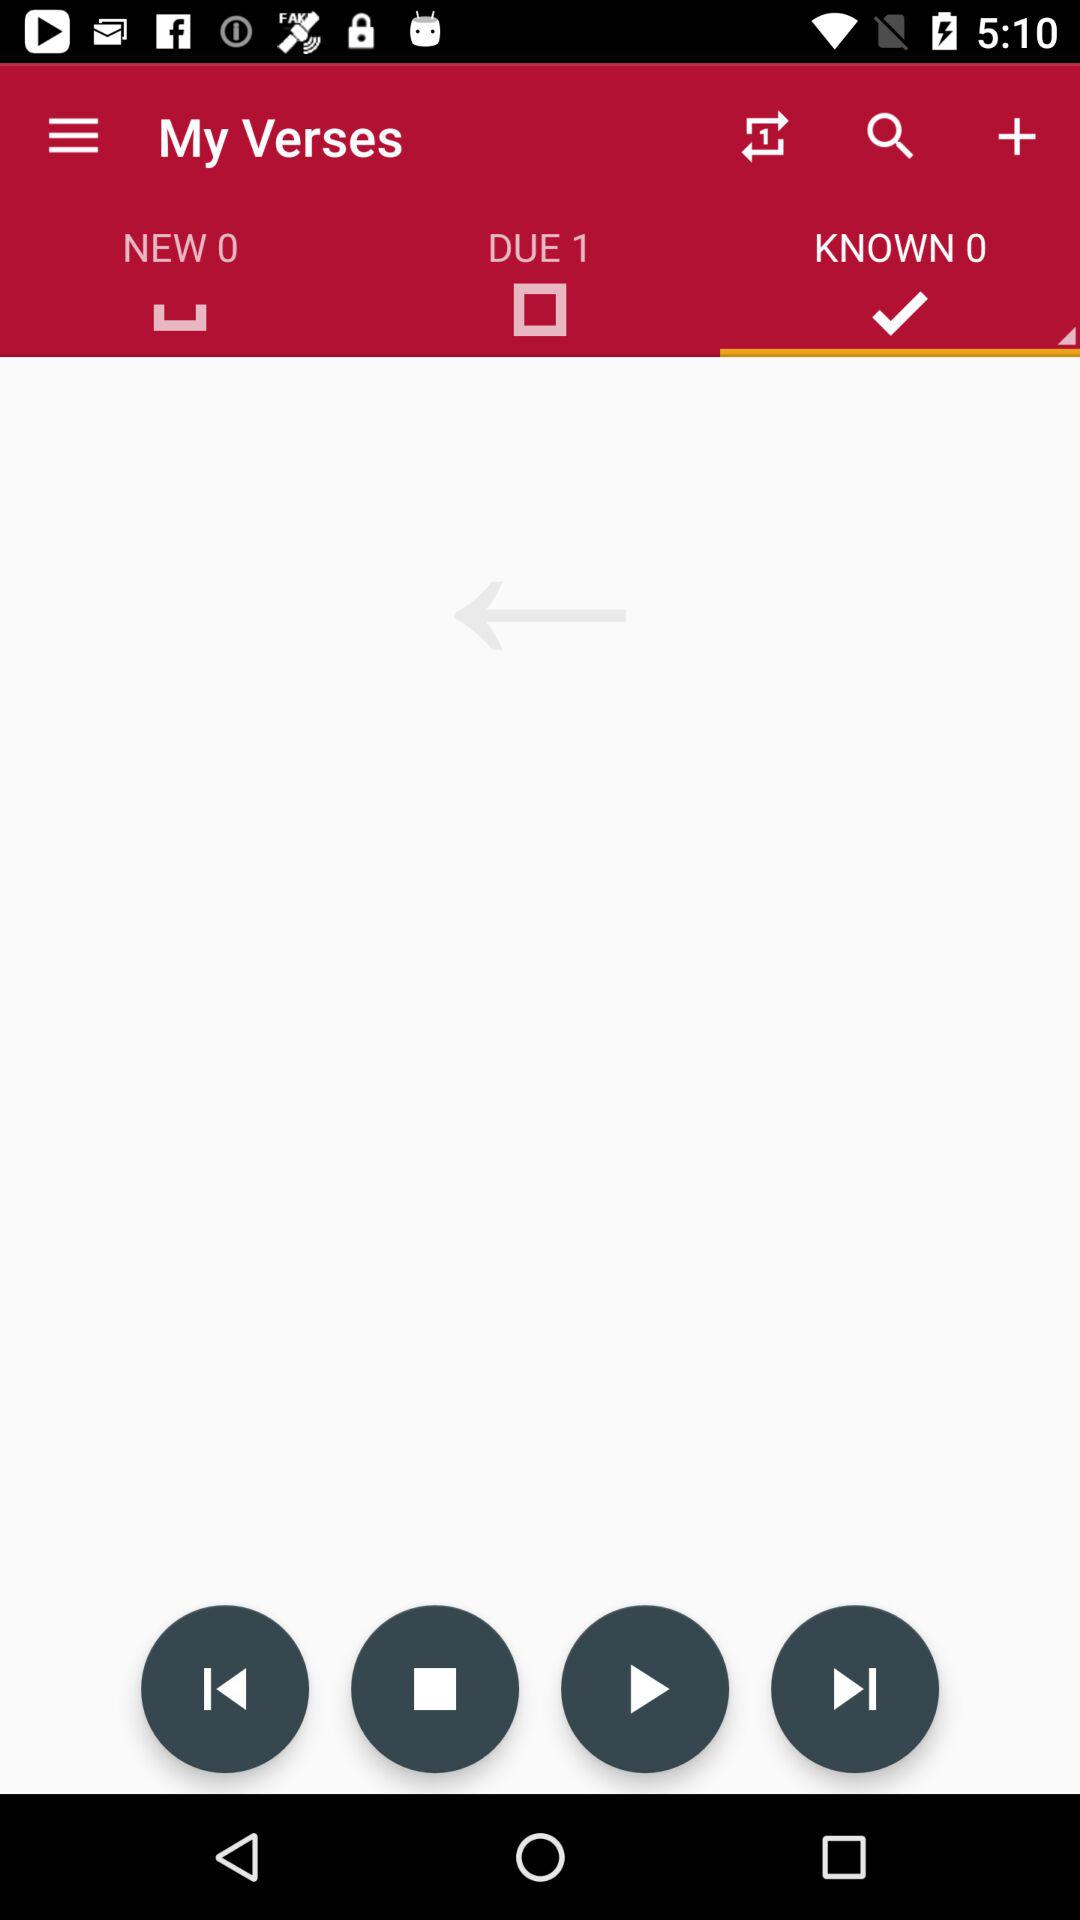What is the number count in "KNOWN"? The number count is 0. 